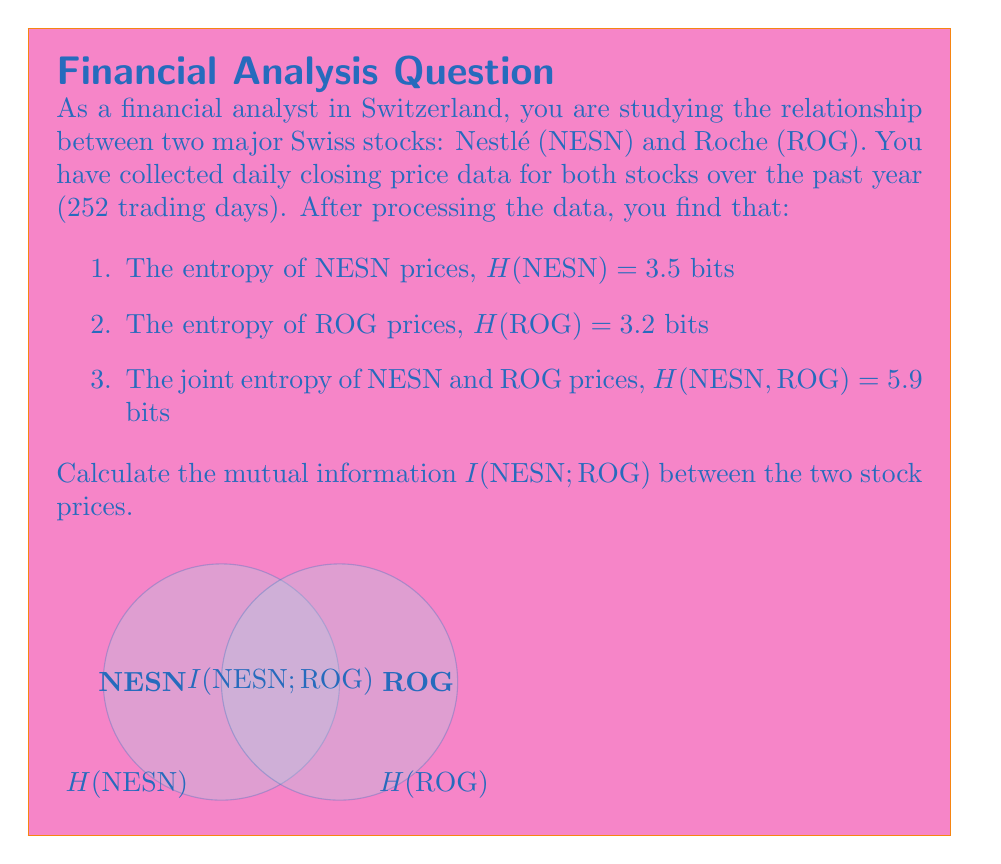Teach me how to tackle this problem. To calculate the mutual information between NESN and ROG stock prices, we'll follow these steps:

1. Recall the formula for mutual information:
   $$I(X;Y) = H(X) + H(Y) - H(X,Y)$$
   where H(X) and H(Y) are the individual entropies, and H(X,Y) is the joint entropy.

2. We have the following information:
   H(NESN) = 3.5 bits
   H(ROG) = 3.2 bits
   H(NESN, ROG) = 5.9 bits

3. Plug these values into the mutual information formula:
   $$I(NESN;ROG) = H(NESN) + H(ROG) - H(NESN,ROG)$$
   $$I(NESN;ROG) = 3.5 + 3.2 - 5.9$$

4. Calculate the result:
   $$I(NESN;ROG) = 0.8 \text{ bits}$$

The mutual information of 0.8 bits indicates the amount of information shared between the two stock prices. This suggests there is some correlation between NESN and ROG prices, but they are not perfectly dependent on each other.
Answer: 0.8 bits 